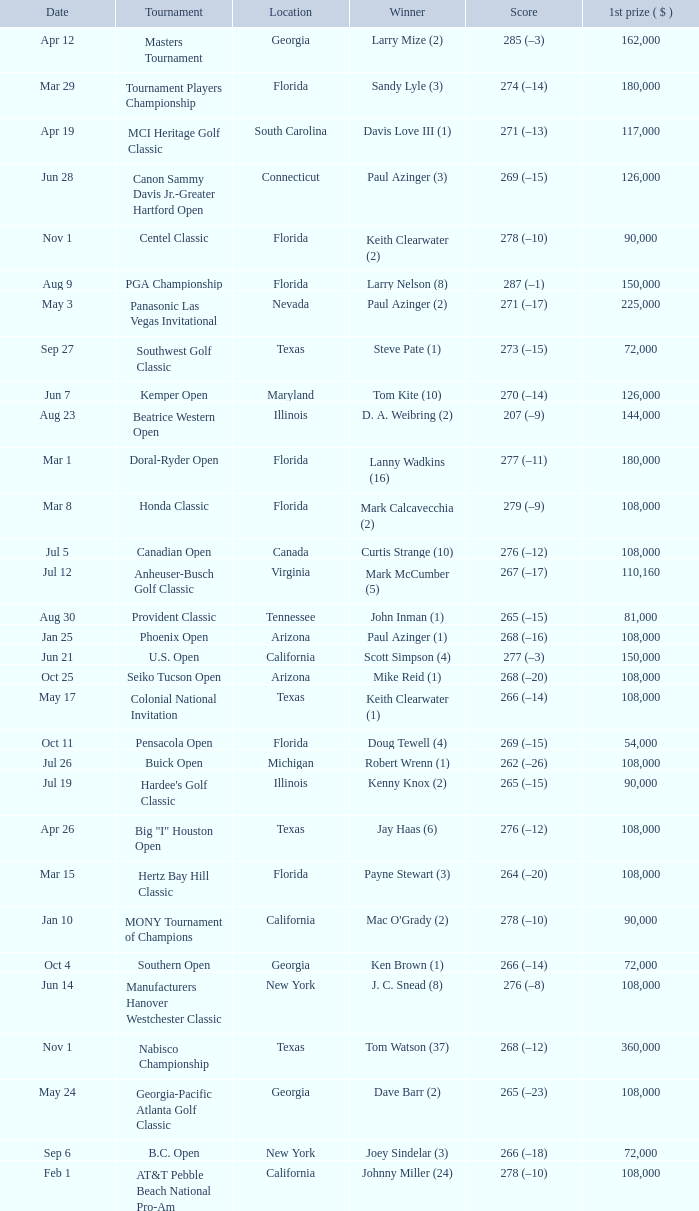What is the date where the winner was Tom Kite (10)? Jun 7. 